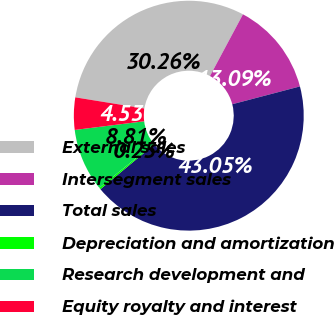Convert chart. <chart><loc_0><loc_0><loc_500><loc_500><pie_chart><fcel>External sales<fcel>Intersegment sales<fcel>Total sales<fcel>Depreciation and amortization<fcel>Research development and<fcel>Equity royalty and interest<nl><fcel>30.26%<fcel>13.09%<fcel>43.05%<fcel>0.25%<fcel>8.81%<fcel>4.53%<nl></chart> 